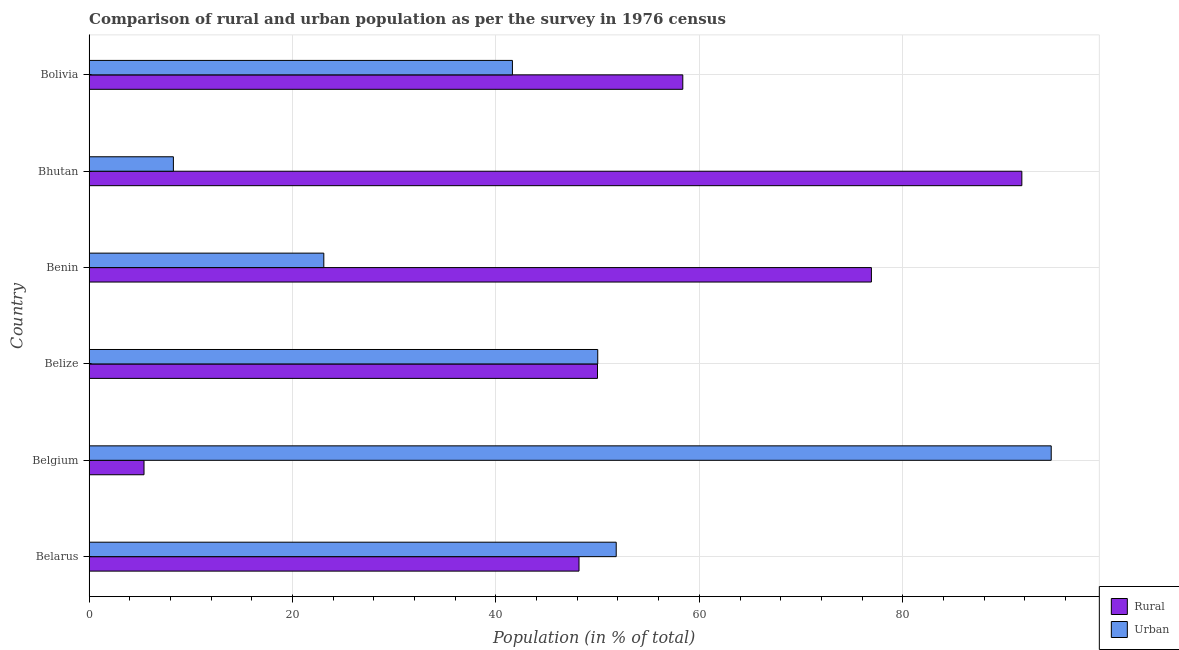In how many cases, is the number of bars for a given country not equal to the number of legend labels?
Give a very brief answer. 0. What is the rural population in Bolivia?
Make the answer very short. 58.38. Across all countries, what is the maximum rural population?
Ensure brevity in your answer.  91.71. Across all countries, what is the minimum urban population?
Offer a very short reply. 8.29. In which country was the rural population maximum?
Your answer should be very brief. Bhutan. In which country was the rural population minimum?
Your answer should be compact. Belgium. What is the total rural population in the graph?
Keep it short and to the point. 330.57. What is the difference between the rural population in Belize and that in Bhutan?
Ensure brevity in your answer.  -41.72. What is the difference between the rural population in Belize and the urban population in Belarus?
Your response must be concise. -1.84. What is the average urban population per country?
Offer a very short reply. 44.91. What is the difference between the urban population and rural population in Bhutan?
Your answer should be compact. -83.42. In how many countries, is the rural population greater than 88 %?
Make the answer very short. 1. What is the ratio of the urban population in Belgium to that in Belize?
Make the answer very short. 1.89. Is the difference between the rural population in Belarus and Bolivia greater than the difference between the urban population in Belarus and Bolivia?
Your answer should be compact. No. What is the difference between the highest and the second highest rural population?
Your response must be concise. 14.79. What is the difference between the highest and the lowest rural population?
Offer a very short reply. 86.31. In how many countries, is the rural population greater than the average rural population taken over all countries?
Make the answer very short. 3. Is the sum of the urban population in Belarus and Belize greater than the maximum rural population across all countries?
Provide a short and direct response. Yes. What does the 1st bar from the top in Benin represents?
Make the answer very short. Urban. What does the 1st bar from the bottom in Belize represents?
Provide a short and direct response. Rural. What is the difference between two consecutive major ticks on the X-axis?
Your answer should be compact. 20. Does the graph contain any zero values?
Your answer should be very brief. No. Does the graph contain grids?
Your answer should be compact. Yes. Where does the legend appear in the graph?
Make the answer very short. Bottom right. What is the title of the graph?
Give a very brief answer. Comparison of rural and urban population as per the survey in 1976 census. Does "Measles" appear as one of the legend labels in the graph?
Your answer should be compact. No. What is the label or title of the X-axis?
Provide a short and direct response. Population (in % of total). What is the label or title of the Y-axis?
Ensure brevity in your answer.  Country. What is the Population (in % of total) of Rural in Belarus?
Offer a very short reply. 48.17. What is the Population (in % of total) of Urban in Belarus?
Give a very brief answer. 51.83. What is the Population (in % of total) of Rural in Belgium?
Ensure brevity in your answer.  5.4. What is the Population (in % of total) in Urban in Belgium?
Make the answer very short. 94.6. What is the Population (in % of total) of Rural in Belize?
Offer a terse response. 49.99. What is the Population (in % of total) of Urban in Belize?
Your answer should be compact. 50.01. What is the Population (in % of total) of Rural in Benin?
Ensure brevity in your answer.  76.92. What is the Population (in % of total) of Urban in Benin?
Give a very brief answer. 23.08. What is the Population (in % of total) of Rural in Bhutan?
Offer a terse response. 91.71. What is the Population (in % of total) in Urban in Bhutan?
Keep it short and to the point. 8.29. What is the Population (in % of total) in Rural in Bolivia?
Your answer should be compact. 58.38. What is the Population (in % of total) of Urban in Bolivia?
Provide a short and direct response. 41.62. Across all countries, what is the maximum Population (in % of total) of Rural?
Give a very brief answer. 91.71. Across all countries, what is the maximum Population (in % of total) of Urban?
Keep it short and to the point. 94.6. Across all countries, what is the minimum Population (in % of total) in Rural?
Ensure brevity in your answer.  5.4. Across all countries, what is the minimum Population (in % of total) in Urban?
Keep it short and to the point. 8.29. What is the total Population (in % of total) of Rural in the graph?
Provide a short and direct response. 330.57. What is the total Population (in % of total) of Urban in the graph?
Provide a short and direct response. 269.43. What is the difference between the Population (in % of total) of Rural in Belarus and that in Belgium?
Provide a succinct answer. 42.77. What is the difference between the Population (in % of total) of Urban in Belarus and that in Belgium?
Offer a terse response. -42.77. What is the difference between the Population (in % of total) in Rural in Belarus and that in Belize?
Your answer should be compact. -1.82. What is the difference between the Population (in % of total) in Urban in Belarus and that in Belize?
Give a very brief answer. 1.82. What is the difference between the Population (in % of total) in Rural in Belarus and that in Benin?
Keep it short and to the point. -28.75. What is the difference between the Population (in % of total) in Urban in Belarus and that in Benin?
Your answer should be very brief. 28.75. What is the difference between the Population (in % of total) in Rural in Belarus and that in Bhutan?
Provide a short and direct response. -43.54. What is the difference between the Population (in % of total) of Urban in Belarus and that in Bhutan?
Your response must be concise. 43.54. What is the difference between the Population (in % of total) of Rural in Belarus and that in Bolivia?
Your answer should be very brief. -10.21. What is the difference between the Population (in % of total) of Urban in Belarus and that in Bolivia?
Your response must be concise. 10.21. What is the difference between the Population (in % of total) of Rural in Belgium and that in Belize?
Keep it short and to the point. -44.59. What is the difference between the Population (in % of total) of Urban in Belgium and that in Belize?
Ensure brevity in your answer.  44.59. What is the difference between the Population (in % of total) in Rural in Belgium and that in Benin?
Make the answer very short. -71.52. What is the difference between the Population (in % of total) in Urban in Belgium and that in Benin?
Ensure brevity in your answer.  71.52. What is the difference between the Population (in % of total) in Rural in Belgium and that in Bhutan?
Your answer should be compact. -86.31. What is the difference between the Population (in % of total) in Urban in Belgium and that in Bhutan?
Offer a very short reply. 86.31. What is the difference between the Population (in % of total) in Rural in Belgium and that in Bolivia?
Offer a terse response. -52.98. What is the difference between the Population (in % of total) of Urban in Belgium and that in Bolivia?
Provide a short and direct response. 52.98. What is the difference between the Population (in % of total) of Rural in Belize and that in Benin?
Your response must be concise. -26.93. What is the difference between the Population (in % of total) in Urban in Belize and that in Benin?
Offer a terse response. 26.93. What is the difference between the Population (in % of total) in Rural in Belize and that in Bhutan?
Provide a succinct answer. -41.72. What is the difference between the Population (in % of total) of Urban in Belize and that in Bhutan?
Provide a succinct answer. 41.72. What is the difference between the Population (in % of total) of Rural in Belize and that in Bolivia?
Offer a terse response. -8.39. What is the difference between the Population (in % of total) of Urban in Belize and that in Bolivia?
Your answer should be compact. 8.39. What is the difference between the Population (in % of total) of Rural in Benin and that in Bhutan?
Keep it short and to the point. -14.79. What is the difference between the Population (in % of total) of Urban in Benin and that in Bhutan?
Your answer should be compact. 14.79. What is the difference between the Population (in % of total) of Rural in Benin and that in Bolivia?
Give a very brief answer. 18.55. What is the difference between the Population (in % of total) of Urban in Benin and that in Bolivia?
Your answer should be very brief. -18.55. What is the difference between the Population (in % of total) in Rural in Bhutan and that in Bolivia?
Provide a succinct answer. 33.34. What is the difference between the Population (in % of total) in Urban in Bhutan and that in Bolivia?
Your answer should be very brief. -33.34. What is the difference between the Population (in % of total) in Rural in Belarus and the Population (in % of total) in Urban in Belgium?
Your answer should be very brief. -46.43. What is the difference between the Population (in % of total) of Rural in Belarus and the Population (in % of total) of Urban in Belize?
Your response must be concise. -1.84. What is the difference between the Population (in % of total) in Rural in Belarus and the Population (in % of total) in Urban in Benin?
Keep it short and to the point. 25.09. What is the difference between the Population (in % of total) of Rural in Belarus and the Population (in % of total) of Urban in Bhutan?
Provide a succinct answer. 39.88. What is the difference between the Population (in % of total) of Rural in Belarus and the Population (in % of total) of Urban in Bolivia?
Your answer should be compact. 6.55. What is the difference between the Population (in % of total) of Rural in Belgium and the Population (in % of total) of Urban in Belize?
Provide a short and direct response. -44.61. What is the difference between the Population (in % of total) of Rural in Belgium and the Population (in % of total) of Urban in Benin?
Offer a very short reply. -17.68. What is the difference between the Population (in % of total) of Rural in Belgium and the Population (in % of total) of Urban in Bhutan?
Provide a short and direct response. -2.89. What is the difference between the Population (in % of total) in Rural in Belgium and the Population (in % of total) in Urban in Bolivia?
Your answer should be compact. -36.22. What is the difference between the Population (in % of total) of Rural in Belize and the Population (in % of total) of Urban in Benin?
Provide a short and direct response. 26.91. What is the difference between the Population (in % of total) in Rural in Belize and the Population (in % of total) in Urban in Bhutan?
Your response must be concise. 41.7. What is the difference between the Population (in % of total) of Rural in Belize and the Population (in % of total) of Urban in Bolivia?
Your response must be concise. 8.36. What is the difference between the Population (in % of total) in Rural in Benin and the Population (in % of total) in Urban in Bhutan?
Make the answer very short. 68.63. What is the difference between the Population (in % of total) in Rural in Benin and the Population (in % of total) in Urban in Bolivia?
Ensure brevity in your answer.  35.3. What is the difference between the Population (in % of total) of Rural in Bhutan and the Population (in % of total) of Urban in Bolivia?
Provide a succinct answer. 50.09. What is the average Population (in % of total) in Rural per country?
Offer a very short reply. 55.09. What is the average Population (in % of total) of Urban per country?
Ensure brevity in your answer.  44.91. What is the difference between the Population (in % of total) in Rural and Population (in % of total) in Urban in Belarus?
Your answer should be compact. -3.66. What is the difference between the Population (in % of total) of Rural and Population (in % of total) of Urban in Belgium?
Provide a succinct answer. -89.2. What is the difference between the Population (in % of total) of Rural and Population (in % of total) of Urban in Belize?
Keep it short and to the point. -0.02. What is the difference between the Population (in % of total) in Rural and Population (in % of total) in Urban in Benin?
Your response must be concise. 53.84. What is the difference between the Population (in % of total) of Rural and Population (in % of total) of Urban in Bhutan?
Your response must be concise. 83.42. What is the difference between the Population (in % of total) in Rural and Population (in % of total) in Urban in Bolivia?
Your response must be concise. 16.75. What is the ratio of the Population (in % of total) of Rural in Belarus to that in Belgium?
Ensure brevity in your answer.  8.92. What is the ratio of the Population (in % of total) of Urban in Belarus to that in Belgium?
Give a very brief answer. 0.55. What is the ratio of the Population (in % of total) in Rural in Belarus to that in Belize?
Provide a short and direct response. 0.96. What is the ratio of the Population (in % of total) of Urban in Belarus to that in Belize?
Your answer should be compact. 1.04. What is the ratio of the Population (in % of total) of Rural in Belarus to that in Benin?
Make the answer very short. 0.63. What is the ratio of the Population (in % of total) in Urban in Belarus to that in Benin?
Keep it short and to the point. 2.25. What is the ratio of the Population (in % of total) in Rural in Belarus to that in Bhutan?
Provide a succinct answer. 0.53. What is the ratio of the Population (in % of total) of Urban in Belarus to that in Bhutan?
Provide a succinct answer. 6.25. What is the ratio of the Population (in % of total) in Rural in Belarus to that in Bolivia?
Your answer should be compact. 0.83. What is the ratio of the Population (in % of total) of Urban in Belarus to that in Bolivia?
Provide a short and direct response. 1.25. What is the ratio of the Population (in % of total) in Rural in Belgium to that in Belize?
Your answer should be compact. 0.11. What is the ratio of the Population (in % of total) of Urban in Belgium to that in Belize?
Your response must be concise. 1.89. What is the ratio of the Population (in % of total) of Rural in Belgium to that in Benin?
Ensure brevity in your answer.  0.07. What is the ratio of the Population (in % of total) of Urban in Belgium to that in Benin?
Offer a terse response. 4.1. What is the ratio of the Population (in % of total) of Rural in Belgium to that in Bhutan?
Offer a terse response. 0.06. What is the ratio of the Population (in % of total) of Urban in Belgium to that in Bhutan?
Your response must be concise. 11.41. What is the ratio of the Population (in % of total) in Rural in Belgium to that in Bolivia?
Give a very brief answer. 0.09. What is the ratio of the Population (in % of total) in Urban in Belgium to that in Bolivia?
Keep it short and to the point. 2.27. What is the ratio of the Population (in % of total) in Rural in Belize to that in Benin?
Provide a short and direct response. 0.65. What is the ratio of the Population (in % of total) of Urban in Belize to that in Benin?
Your response must be concise. 2.17. What is the ratio of the Population (in % of total) of Rural in Belize to that in Bhutan?
Ensure brevity in your answer.  0.55. What is the ratio of the Population (in % of total) in Urban in Belize to that in Bhutan?
Give a very brief answer. 6.03. What is the ratio of the Population (in % of total) of Rural in Belize to that in Bolivia?
Your answer should be very brief. 0.86. What is the ratio of the Population (in % of total) of Urban in Belize to that in Bolivia?
Ensure brevity in your answer.  1.2. What is the ratio of the Population (in % of total) in Rural in Benin to that in Bhutan?
Provide a succinct answer. 0.84. What is the ratio of the Population (in % of total) of Urban in Benin to that in Bhutan?
Give a very brief answer. 2.78. What is the ratio of the Population (in % of total) of Rural in Benin to that in Bolivia?
Your response must be concise. 1.32. What is the ratio of the Population (in % of total) of Urban in Benin to that in Bolivia?
Give a very brief answer. 0.55. What is the ratio of the Population (in % of total) of Rural in Bhutan to that in Bolivia?
Your answer should be very brief. 1.57. What is the ratio of the Population (in % of total) of Urban in Bhutan to that in Bolivia?
Provide a short and direct response. 0.2. What is the difference between the highest and the second highest Population (in % of total) of Rural?
Offer a terse response. 14.79. What is the difference between the highest and the second highest Population (in % of total) in Urban?
Your answer should be very brief. 42.77. What is the difference between the highest and the lowest Population (in % of total) in Rural?
Keep it short and to the point. 86.31. What is the difference between the highest and the lowest Population (in % of total) of Urban?
Provide a short and direct response. 86.31. 